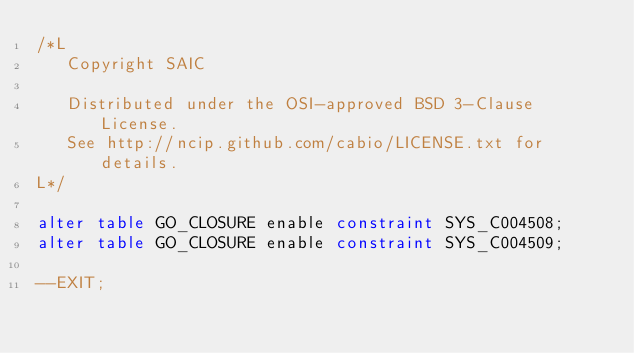<code> <loc_0><loc_0><loc_500><loc_500><_SQL_>/*L
   Copyright SAIC

   Distributed under the OSI-approved BSD 3-Clause License.
   See http://ncip.github.com/cabio/LICENSE.txt for details.
L*/

alter table GO_CLOSURE enable constraint SYS_C004508;
alter table GO_CLOSURE enable constraint SYS_C004509;

--EXIT;
</code> 